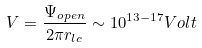Convert formula to latex. <formula><loc_0><loc_0><loc_500><loc_500>V = \frac { \Psi _ { o p e n } } { 2 \pi r _ { l c } } \sim 1 0 ^ { 1 3 - 1 7 } V o l t</formula> 